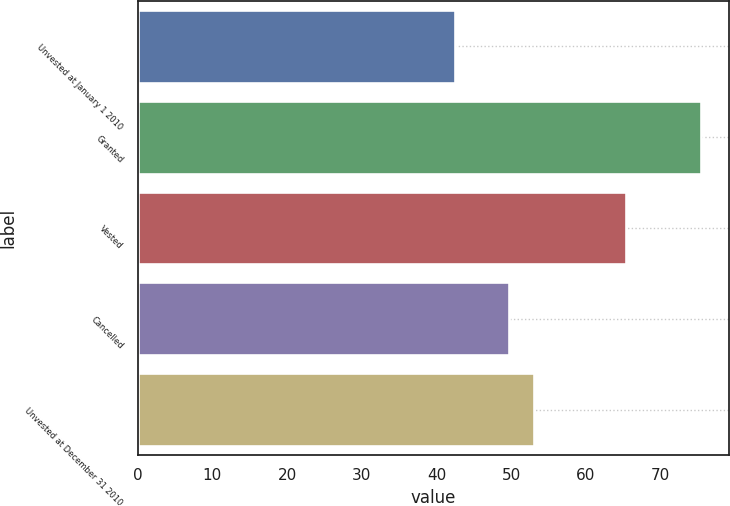<chart> <loc_0><loc_0><loc_500><loc_500><bar_chart><fcel>Unvested at January 1 2010<fcel>Granted<fcel>Vested<fcel>Cancelled<fcel>Unvested at December 31 2010<nl><fcel>42.52<fcel>75.37<fcel>65.33<fcel>49.74<fcel>53.03<nl></chart> 